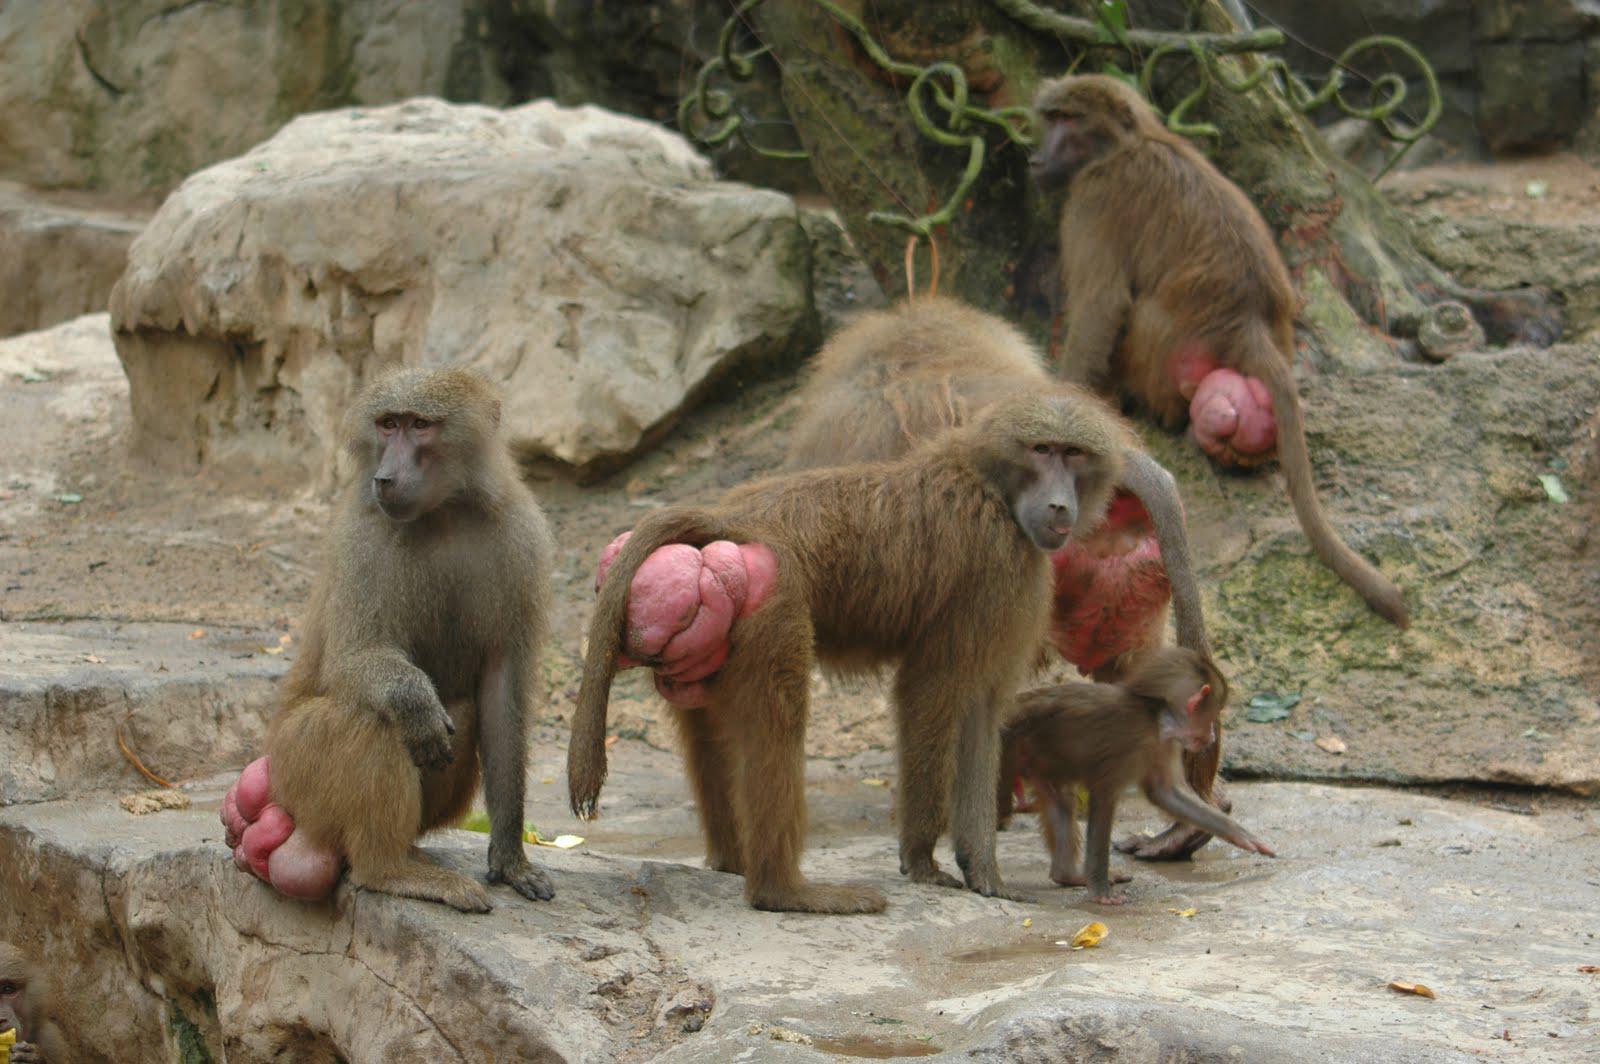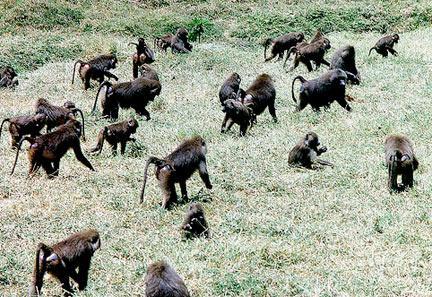The first image is the image on the left, the second image is the image on the right. Given the left and right images, does the statement "An image shows at least 10 monkeys on a green field." hold true? Answer yes or no. Yes. The first image is the image on the left, the second image is the image on the right. For the images displayed, is the sentence "There are more than seven monkeys in the image on the right." factually correct? Answer yes or no. Yes. 